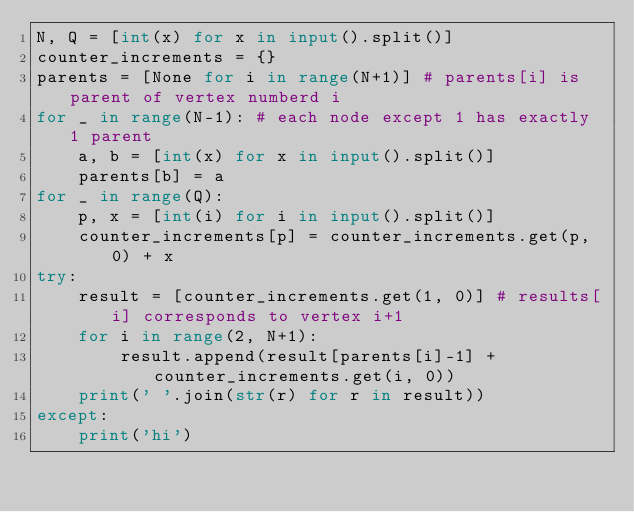<code> <loc_0><loc_0><loc_500><loc_500><_Python_>N, Q = [int(x) for x in input().split()]
counter_increments = {}
parents = [None for i in range(N+1)] # parents[i] is parent of vertex numberd i
for _ in range(N-1): # each node except 1 has exactly 1 parent
    a, b = [int(x) for x in input().split()]
    parents[b] = a
for _ in range(Q):
    p, x = [int(i) for i in input().split()]
    counter_increments[p] = counter_increments.get(p, 0) + x
try:
    result = [counter_increments.get(1, 0)] # results[i] corresponds to vertex i+1
    for i in range(2, N+1):
        result.append(result[parents[i]-1] + counter_increments.get(i, 0))
    print(' '.join(str(r) for r in result))
except:
    print('hi')</code> 